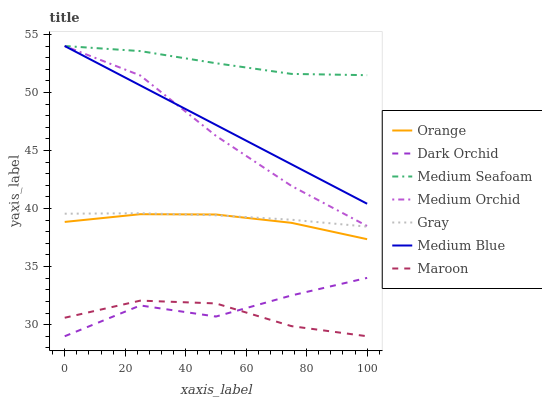Does Medium Orchid have the minimum area under the curve?
Answer yes or no. No. Does Medium Orchid have the maximum area under the curve?
Answer yes or no. No. Is Medium Orchid the smoothest?
Answer yes or no. No. Is Medium Orchid the roughest?
Answer yes or no. No. Does Medium Orchid have the lowest value?
Answer yes or no. No. Does Dark Orchid have the highest value?
Answer yes or no. No. Is Dark Orchid less than Medium Orchid?
Answer yes or no. Yes. Is Medium Blue greater than Orange?
Answer yes or no. Yes. Does Dark Orchid intersect Medium Orchid?
Answer yes or no. No. 